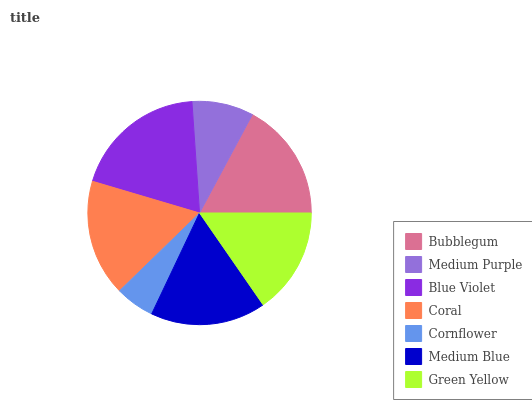Is Cornflower the minimum?
Answer yes or no. Yes. Is Blue Violet the maximum?
Answer yes or no. Yes. Is Medium Purple the minimum?
Answer yes or no. No. Is Medium Purple the maximum?
Answer yes or no. No. Is Bubblegum greater than Medium Purple?
Answer yes or no. Yes. Is Medium Purple less than Bubblegum?
Answer yes or no. Yes. Is Medium Purple greater than Bubblegum?
Answer yes or no. No. Is Bubblegum less than Medium Purple?
Answer yes or no. No. Is Medium Blue the high median?
Answer yes or no. Yes. Is Medium Blue the low median?
Answer yes or no. Yes. Is Bubblegum the high median?
Answer yes or no. No. Is Cornflower the low median?
Answer yes or no. No. 